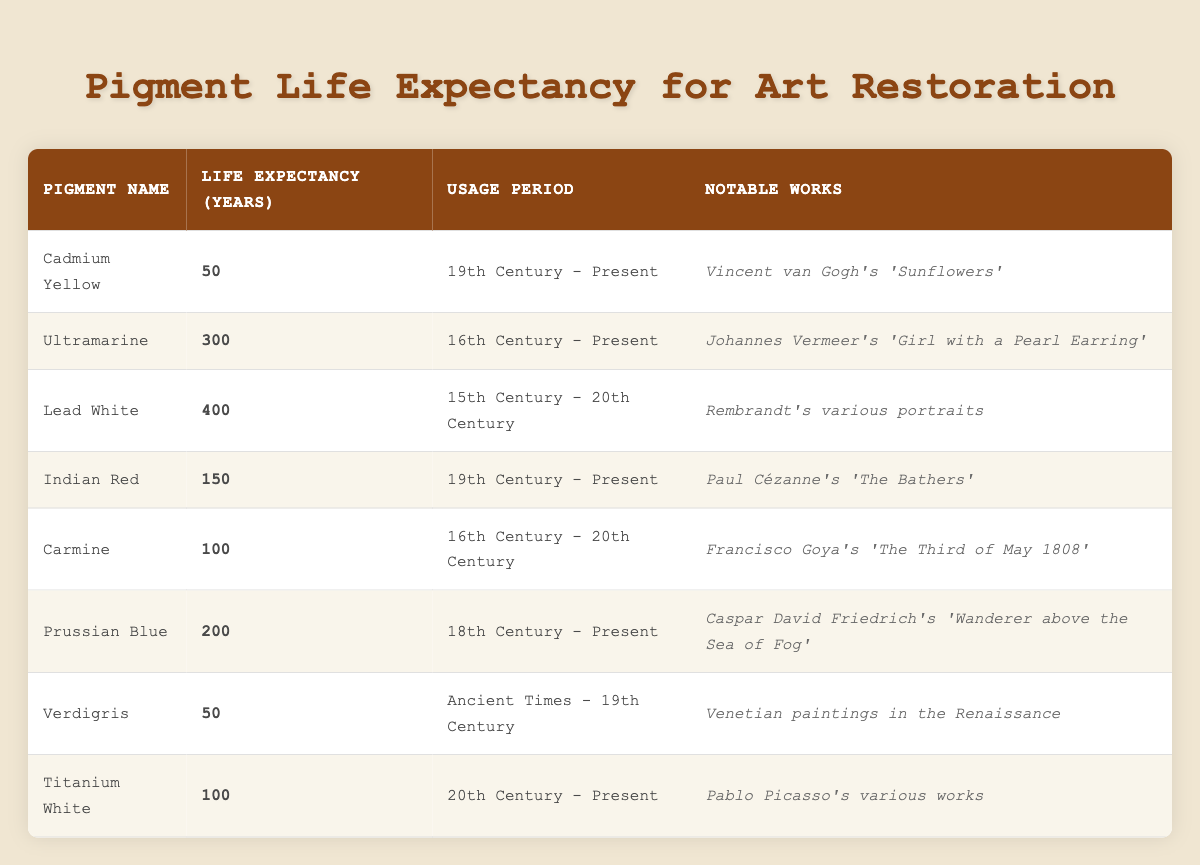What is the life expectancy of Cadmium Yellow? The table lists "Cadmium Yellow" with a life expectancy of 50 years.
Answer: 50 Which pigment has the longest life expectancy? By reviewing the table, Lead White has the highest value at 400 years, surpassing all other pigments.
Answer: Lead White Is Titanium White used in artworks from the 19th Century? The usage period for Titanium White is "20th Century - Present," indicating it is not used in the 19th Century.
Answer: No How many pigments have a life expectancy of 100 years? The table shows two pigments with a life expectancy of 100 years: Carmine and Titanium White. Adding them gives us a total count of 2.
Answer: 2 What is the average life expectancy of pigments used in the 19th Century? The pigments from the 19th Century are Cadmium Yellow, Indian Red, and Verdigris. Their life expectancies are 50, 150, and 50 years, respectively. Calculating the average involves summing these values (50 + 150 + 50) = 250, then dividing by 3, which gives an average of 250/3 = 83.33.
Answer: 83.33 Which notable work is associated with Carmine? The table states that Carmine is associated with Francisco Goya's "The Third of May 1808."
Answer: Francisco Goya's "The Third of May 1808" How many pigments are used from ancient times until the 19th Century? The pigments from that period are Verdigris, which was used from "Ancient Times - 19th Century." Thus, there is only one pigment in this category, leading to a total count of 1.
Answer: 1 How does the life expectancy of Ultramarine compare to that of Prussian Blue? Ultramarine has a life expectancy of 300 years, while Prussian Blue has 200 years. The difference between them is 300 - 200 = 100 years, making Ultramarine last significantly longer.
Answer: 100 years difference Are there any pigments used in historical art that have a life expectancy of 50 years? The table lists both Cadmium Yellow and Verdigris, each with a life expectancy of 50 years. Therefore, the answer is yes; two pigments have this life expectancy.
Answer: Yes 